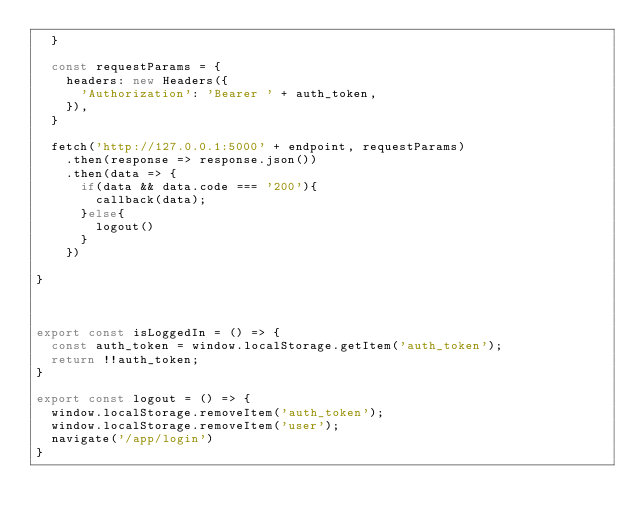Convert code to text. <code><loc_0><loc_0><loc_500><loc_500><_JavaScript_>  }

  const requestParams = {
    headers: new Headers({
      'Authorization': 'Bearer ' + auth_token,
    }),
  }

  fetch('http://127.0.0.1:5000' + endpoint, requestParams)
    .then(response => response.json())
    .then(data => {
      if(data && data.code === '200'){
        callback(data);
      }else{
        logout()
      }
    })

}



export const isLoggedIn = () => {
  const auth_token = window.localStorage.getItem('auth_token');
  return !!auth_token;
}

export const logout = () => {
  window.localStorage.removeItem('auth_token');
  window.localStorage.removeItem('user');
  navigate('/app/login')
}
</code> 